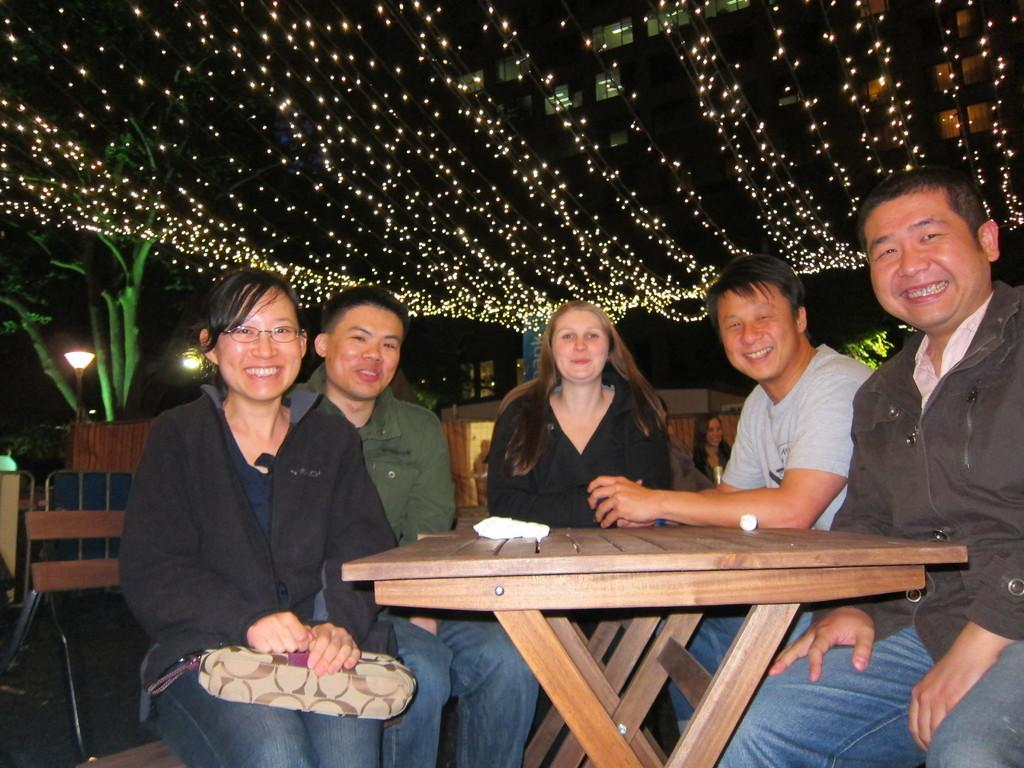How many people are in the image? There are five people in the image, two women and three men. What are the people doing in the image? The people are sitting on chairs. Can you describe what one of the women is holding? One woman is holding a bag. What is present on the table in the image? There is a paper on a table. What can be seen in the background of the image? There is a plant and lights visible in the background. How far away is the cannon from the people in the image? There is no cannon present in the image. Can you tell me how many skateboards are visible in the image? There are no skateboards visible in the image. 